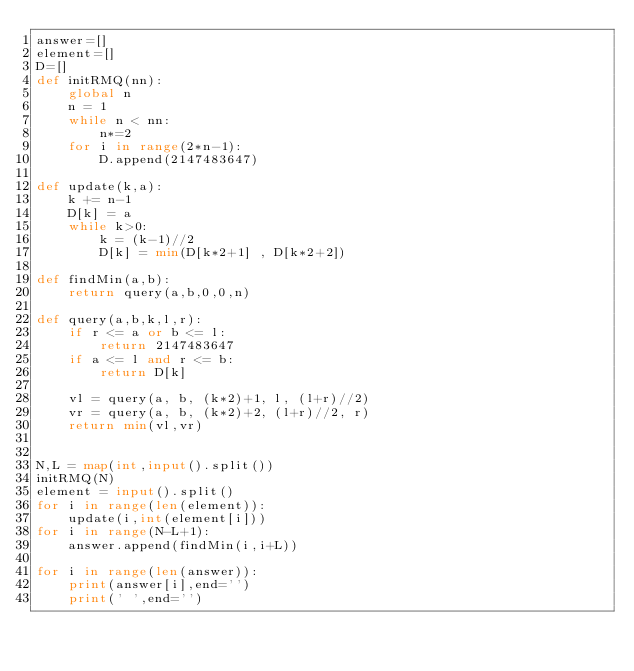Convert code to text. <code><loc_0><loc_0><loc_500><loc_500><_Python_>answer=[]
element=[]
D=[]
def initRMQ(nn):
    global n
    n = 1
    while n < nn:
        n*=2
    for i in range(2*n-1):
        D.append(2147483647)

def update(k,a):
    k += n-1
    D[k] = a
    while k>0:
        k = (k-1)//2
        D[k] = min(D[k*2+1] , D[k*2+2])
        
def findMin(a,b):
    return query(a,b,0,0,n)

def query(a,b,k,l,r):
    if r <= a or b <= l:
        return 2147483647
    if a <= l and r <= b:
        return D[k]
    
    vl = query(a, b, (k*2)+1, l, (l+r)//2)
    vr = query(a, b, (k*2)+2, (l+r)//2, r)
    return min(vl,vr)


N,L = map(int,input().split())
initRMQ(N)
element = input().split()
for i in range(len(element)):
    update(i,int(element[i]))
for i in range(N-L+1):
    answer.append(findMin(i,i+L))
            
for i in range(len(answer)):
    print(answer[i],end='')
    print(' ',end='')
</code> 